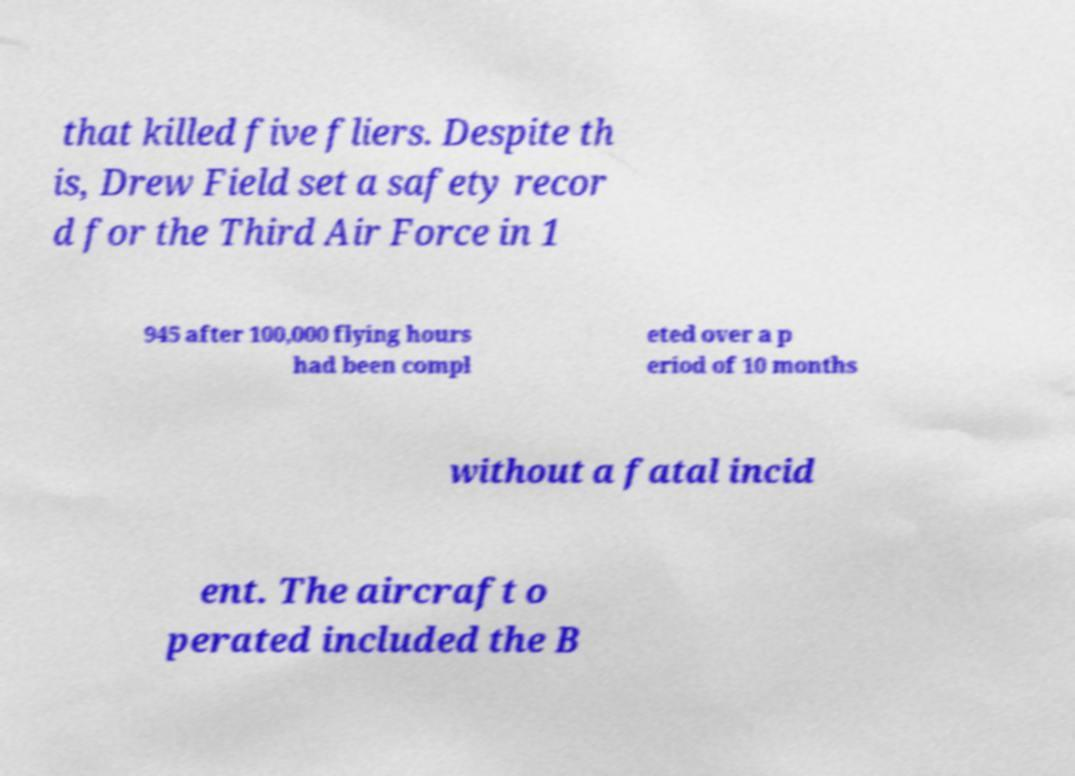Please identify and transcribe the text found in this image. that killed five fliers. Despite th is, Drew Field set a safety recor d for the Third Air Force in 1 945 after 100,000 flying hours had been compl eted over a p eriod of 10 months without a fatal incid ent. The aircraft o perated included the B 